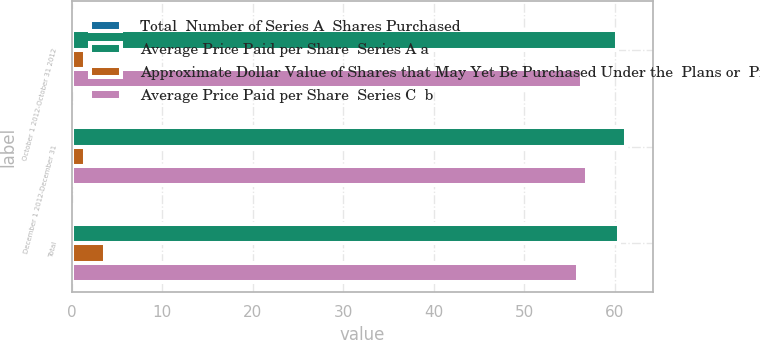Convert chart to OTSL. <chart><loc_0><loc_0><loc_500><loc_500><stacked_bar_chart><ecel><fcel>October 1 2012-October 31 2012<fcel>December 1 2012-December 31<fcel>Total<nl><fcel>Total  Number of Series A  Shares Purchased<fcel>0.3<fcel>0.1<fcel>0.4<nl><fcel>Average Price Paid per Share  Series A a<fcel>60.24<fcel>61.2<fcel>60.44<nl><fcel>Approximate Dollar Value of Shares that May Yet Be Purchased Under the  Plans or  Programs ab<fcel>1.5<fcel>1.5<fcel>3.7<nl><fcel>Average Price Paid per Share  Series C  b<fcel>56.37<fcel>56.95<fcel>55.96<nl></chart> 